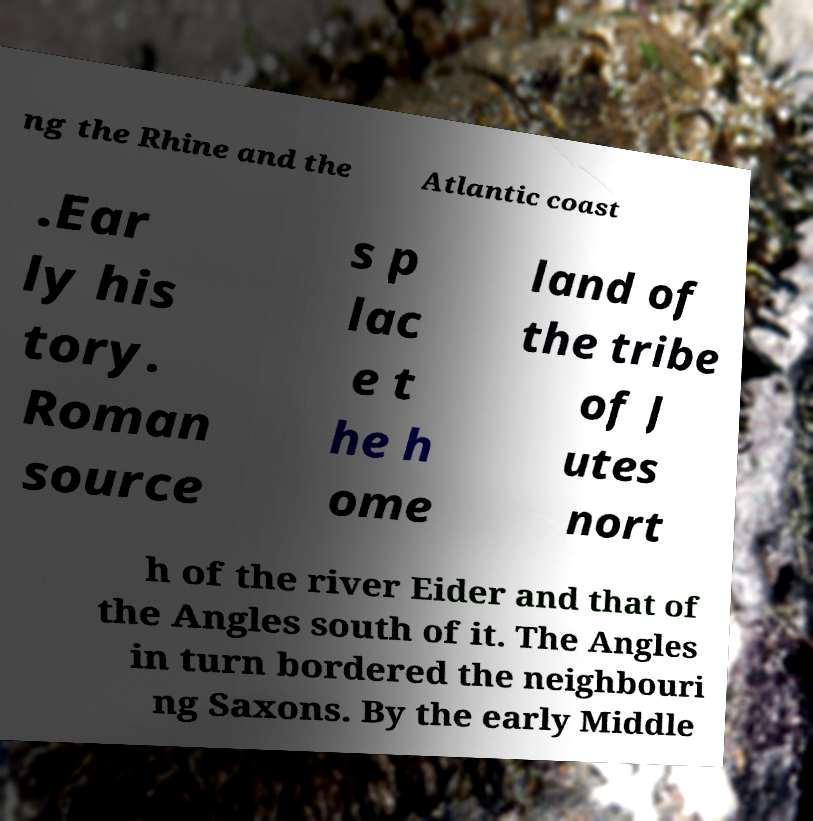Can you accurately transcribe the text from the provided image for me? ng the Rhine and the Atlantic coast .Ear ly his tory. Roman source s p lac e t he h ome land of the tribe of J utes nort h of the river Eider and that of the Angles south of it. The Angles in turn bordered the neighbouri ng Saxons. By the early Middle 